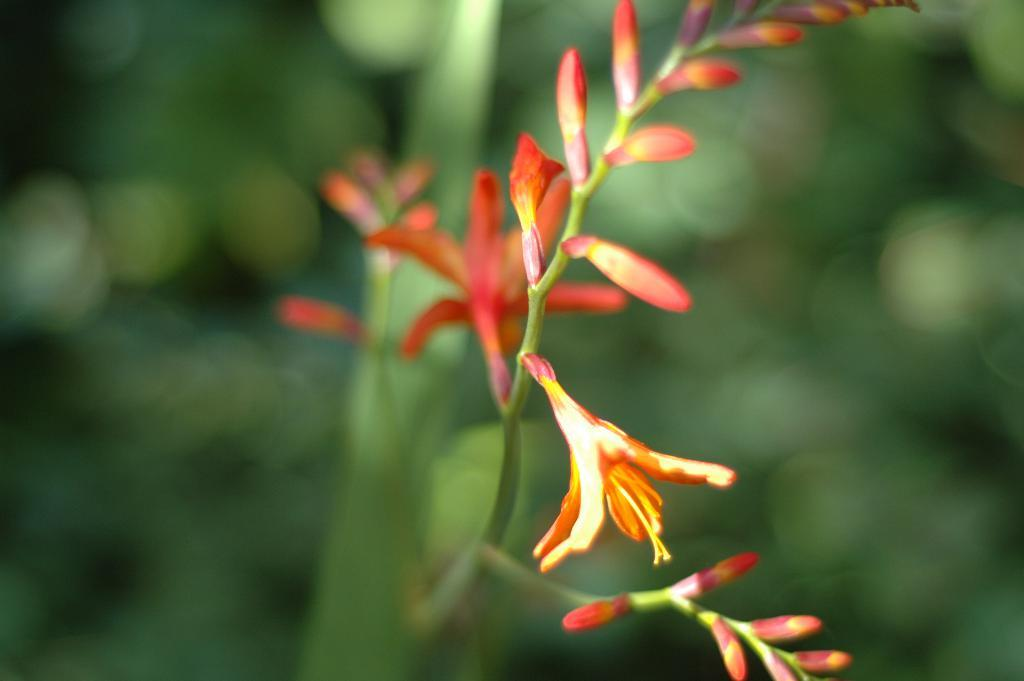What is the main subject of the image? There is a flower in the image. How many women are visible in the frame of the image? There are no women present in the image; it features a flower. What type of ball can be seen interacting with the flower in the image? There is no ball present in the image; it features a flower. 